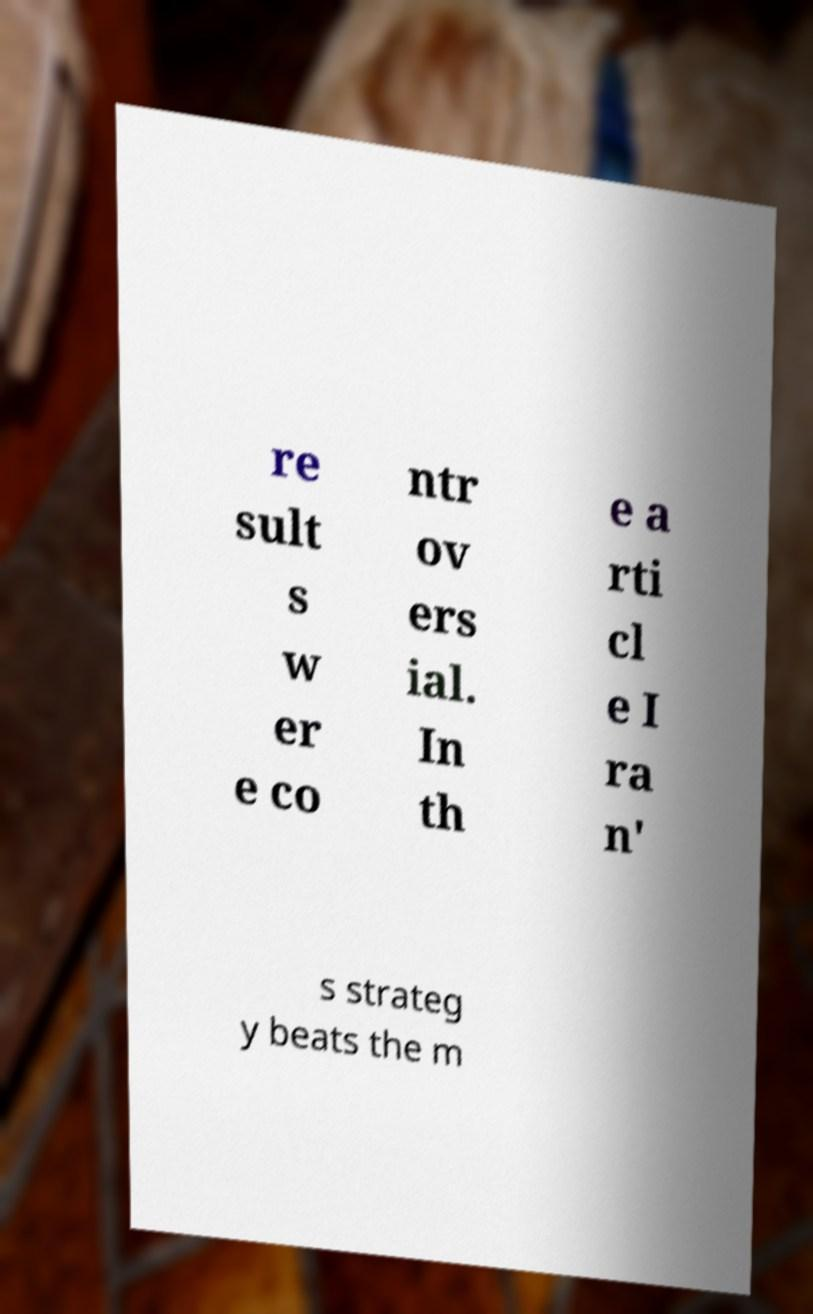Could you assist in decoding the text presented in this image and type it out clearly? re sult s w er e co ntr ov ers ial. In th e a rti cl e I ra n' s strateg y beats the m 